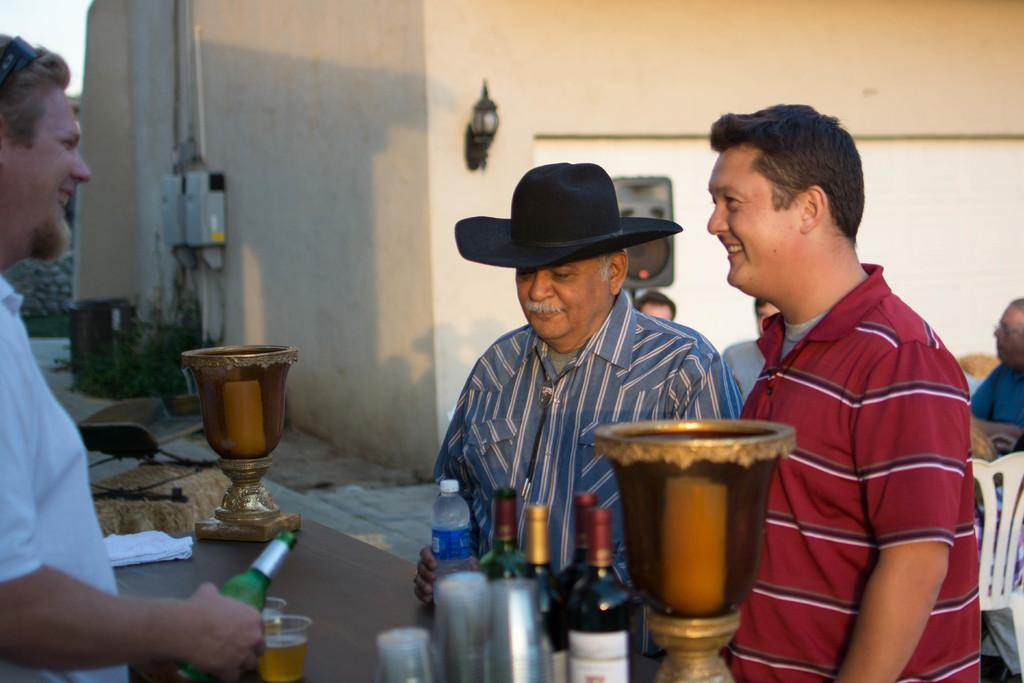How many people are present in the image? There are three people in the image. What are the people holding in their hands? The people are holding bottles. What is the main piece of furniture in the image? There is a table in the image. What items can be seen on the table? There are bottles and glasses on the table. Can you tell me how many ladybugs are crawling on the table in the image? There are no ladybugs present in the image; the table only has bottles and glasses on it. What type of cannon is visible on the table in the image? There is no cannon present in the image; the table only has bottles and glasses on it. 